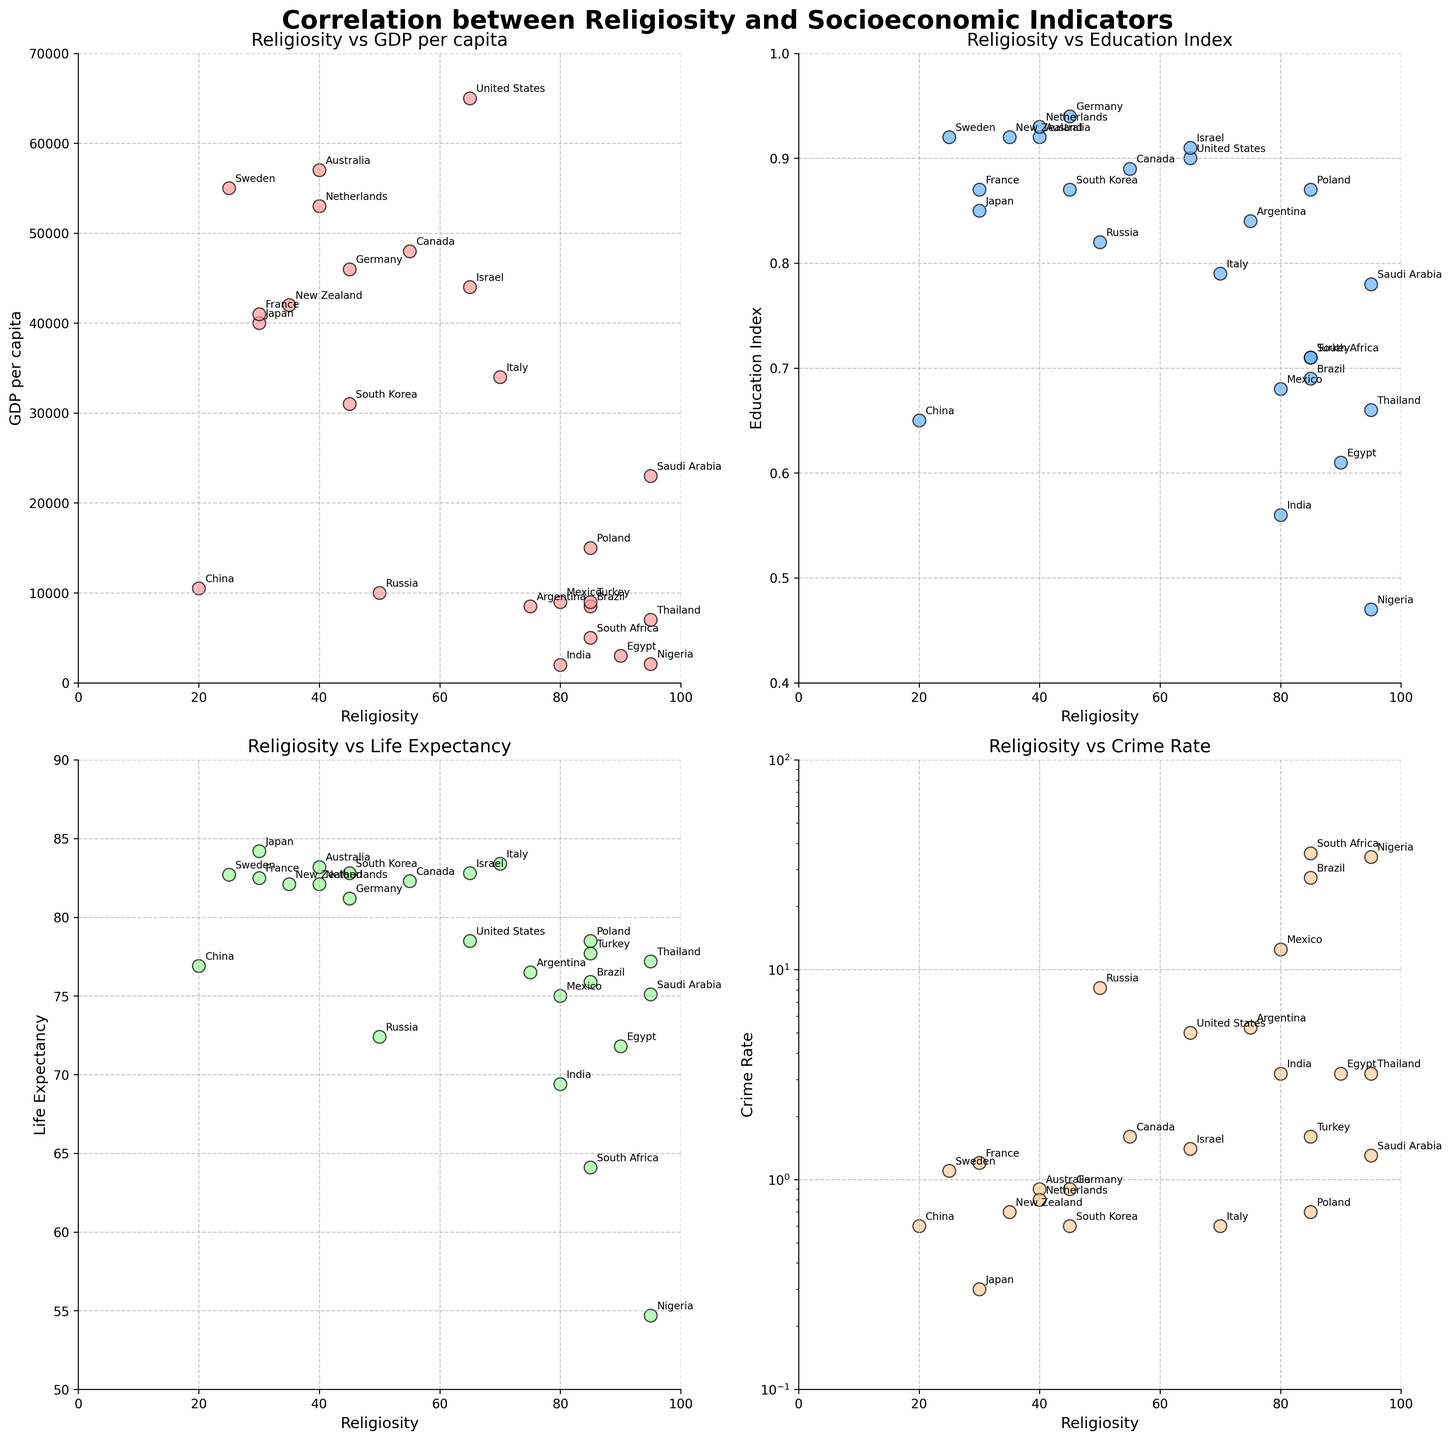What is the relationship between Religiosity and GDP per Capita? By examining the Religiosity vs. GDP per Capita subplot, we can see that countries with higher religiosity levels, such as Nigeria and India, tend to have lower GDP per capita values. Conversely, countries with lower religiosity levels, like the United States, Sweden, and Australia, generally have higher GDP per capita values. This indicates a negative correlation between religiosity and GDP per capita.
Answer: Negative correlation How does the Education Index correlate with Religiosity? Observing the Religiosity vs. Education Index subplot, countries with lower religiosity, such as Sweden, Germany, and Australia, exhibit higher education index values. In contrast, countries with high religiosity, particularly Nigeria and India, show lower education index values. This suggests a negative correlation between religiosity and the education index.
Answer: Negative correlation Which country has the highest life expectancy, and what is its religiosity level? By looking at the Religiosity vs. Life Expectancy subplot, Japan has the highest life expectancy of about 84.2 years. Japan's religiosity level, as indicated in the figure, is 30.
Answer: Japan, 30 Among the countries with the same religiosity level of 85, which country has the highest Crime Rate? From the Religiosity vs. Crime Rate subplot, the countries with a religiosity level of 85 are Brazil, Turkey, Poland, South Africa, and Mexico. Among them, South Africa has the highest crime rate of 35.9.
Answer: South Africa What can you infer about the average life expectancy in countries with religiosity greater than 80? By averaging the life expectancy of countries with religiosity over 80 (Saudi Arabia, Brazil, India, Nigeria, Egypt, Mexico, South Africa, and Thailand), we can calculate the mean value. The life expectancies are 75.1, 75.9, 69.4, 54.7, 71.8, 75.0, 64.1, and 77.2 respectively. Adding these values together gives 563.2, then dividing by the number of countries (8) gives an average of approximately 70.4 years.
Answer: 70.4 years Which country exhibits an outlier behavior in the Crime Rate in terms of its religiosity? In the Religiosity vs. Crime Rate subplot, Nigeria stands out as an outlier. With a religiosity level of 95, it also has a very high crime rate of 34.5 compared to other countries with similar religiosity levels.
Answer: Nigeria Compare the GDP per Capita between countries with a religiosity level below 50. Which country has the lowest value and what is it? For countries with a religiosity level below 50 (Japan, Sweden, Germany, Australia, China, France, South Korea, New Zealand), China has the lowest GDP per capita value of 10500.
Answer: China, 10500 How does crime rate vary with religiosity for countries with a GDP per Capita below 10,000? From the subplots, we filter out countries with GDP per Capita below 10,000 (Brazil, India, Nigeria, Egypt, Mexico, South Africa, Thailand). Brazil and South Africa, which have high religiosity levels of 85, have higher crime rates (27.4 and 35.9, respectively). In contrast, countries like India (80 religiosity) and Egypt (90 religiosity) have lower crime rates (3.2). This indicates that higher religiosity does not consistently correlate with higher or lower crime rates in this subset of countries.
Answer: Mixed correlation Which country has a high Education Index but relatively high religiosity? Considering both the Religiosity vs. Education Index subplot and noting high education index values, Poland (education index 0.87) has a relatively high religiosity score of 85 compared to other countries with similarly high education indices.
Answer: Poland 